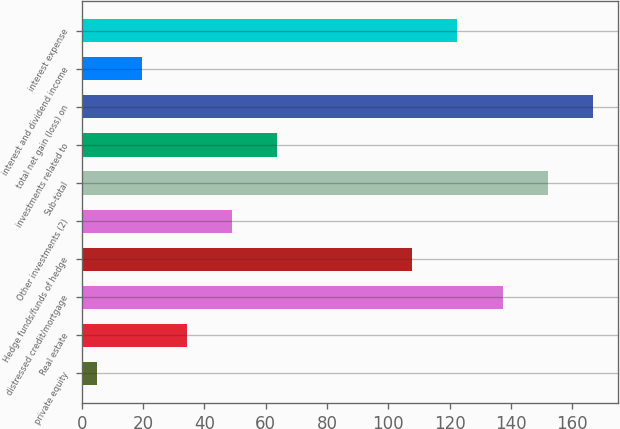<chart> <loc_0><loc_0><loc_500><loc_500><bar_chart><fcel>private equity<fcel>Real estate<fcel>distressed credit/mortgage<fcel>Hedge funds/funds of hedge<fcel>Other investments (2)<fcel>Sub-total<fcel>investments related to<fcel>total net gain (loss) on<fcel>interest and dividend income<fcel>interest expense<nl><fcel>5<fcel>34.4<fcel>137.3<fcel>107.9<fcel>49.1<fcel>152<fcel>63.8<fcel>166.7<fcel>19.7<fcel>122.6<nl></chart> 